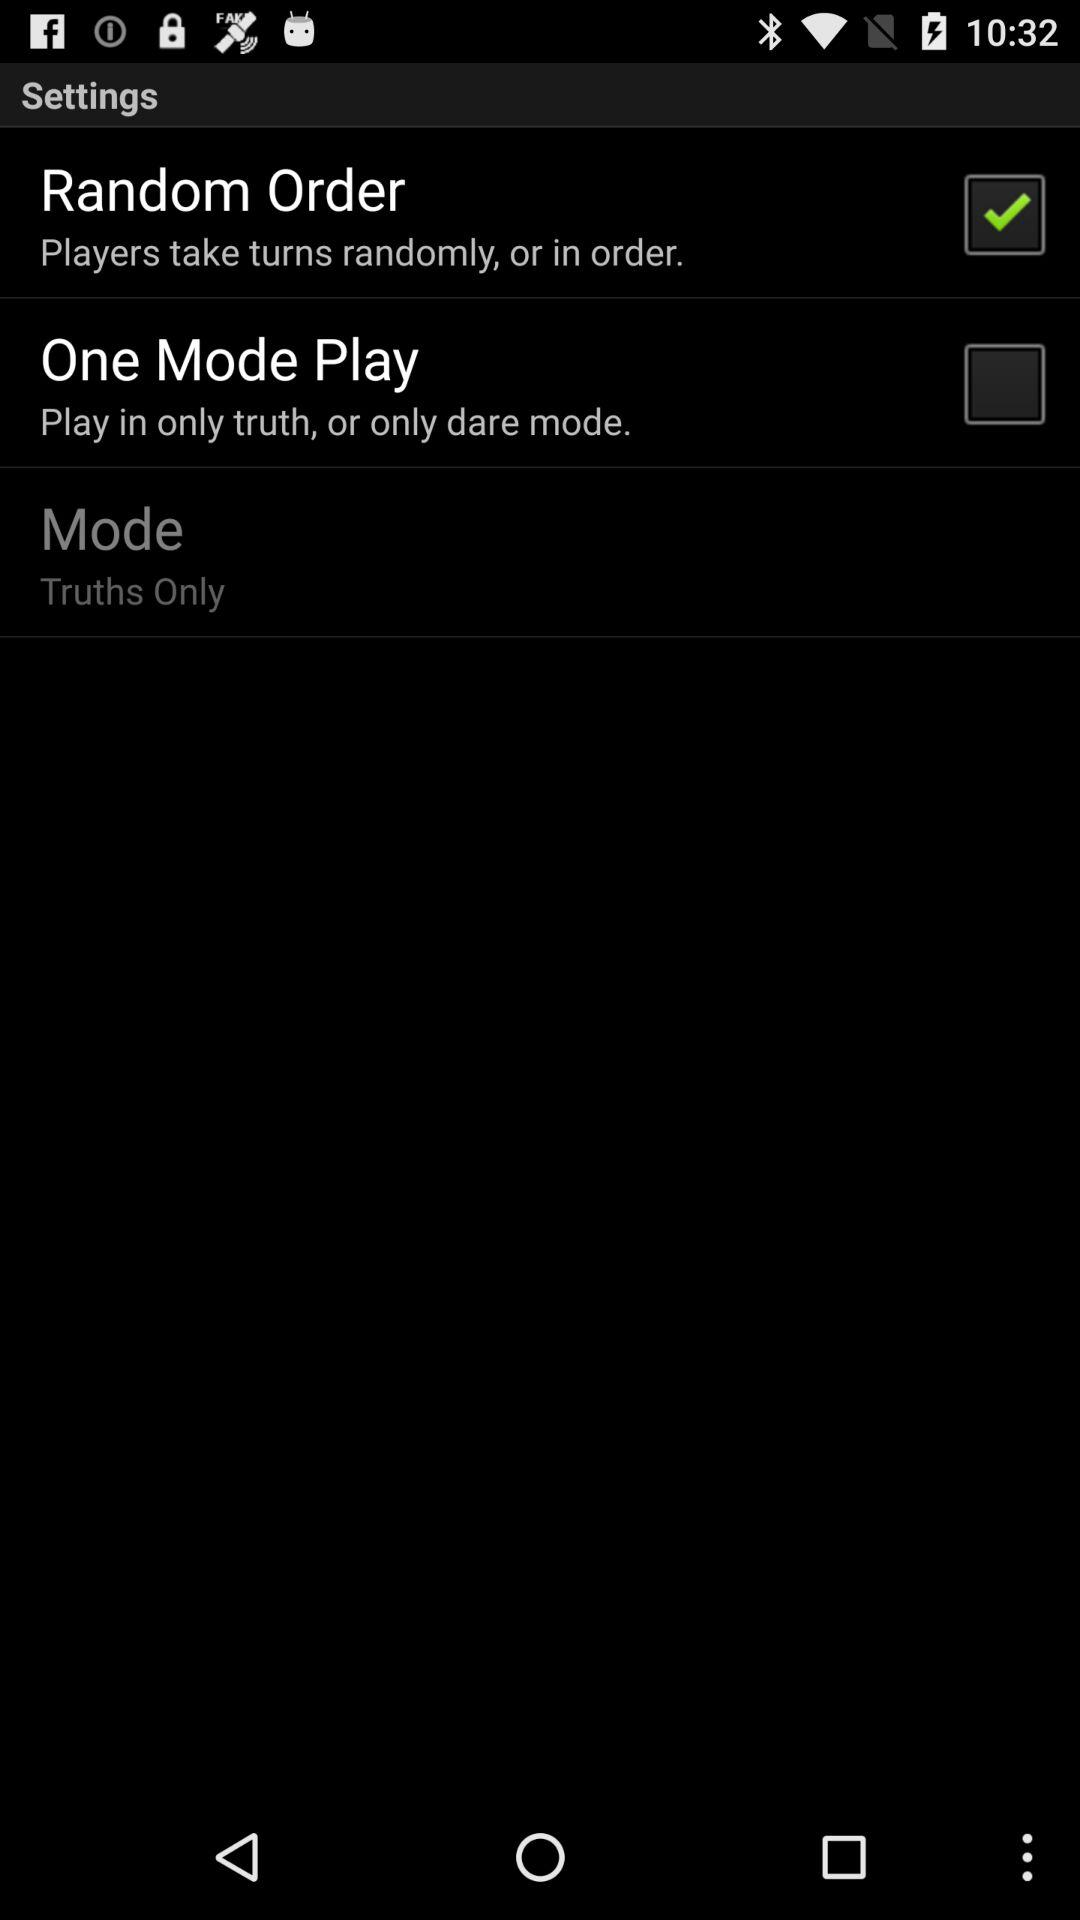What is the status of "One Mode Play"? The status is "off". 